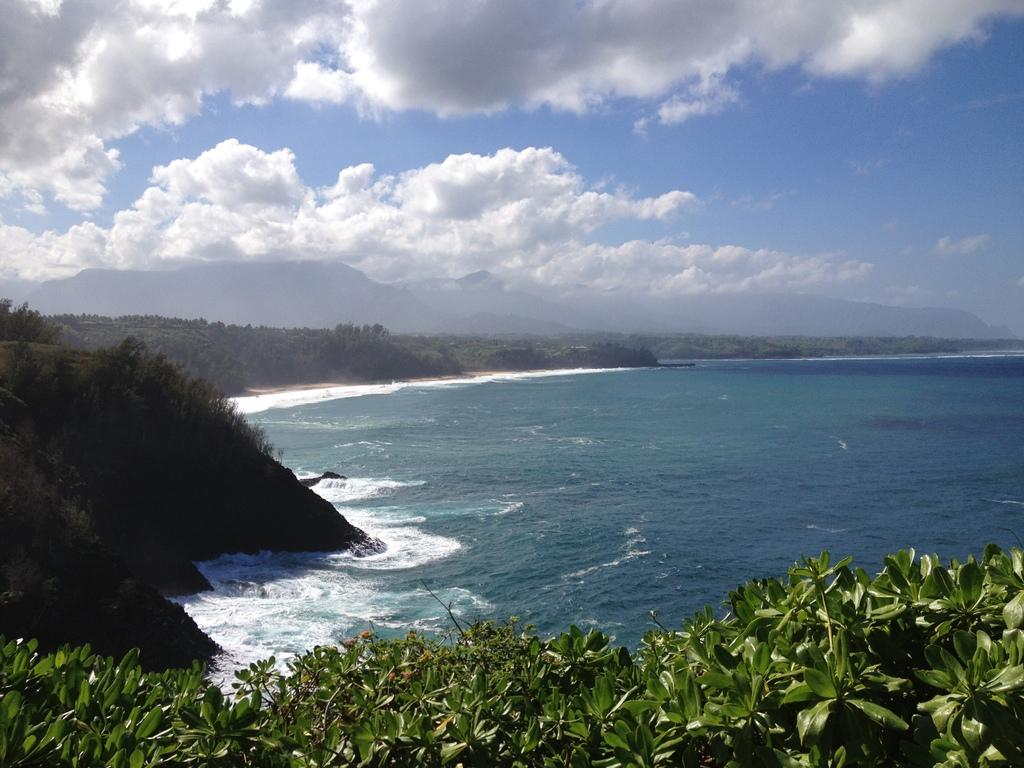What color are the leaves in the image? The leaves in the image are green. What else can be seen in the sky besides the leaves? There are clouds in the image. What part of the natural environment is visible in the image? The sky is visible in the image. What type of hair can be seen on the sun in the image? There is no sun or hair present in the image. How many balloons are floating in the sky in the image? There are no balloons visible in the image. 